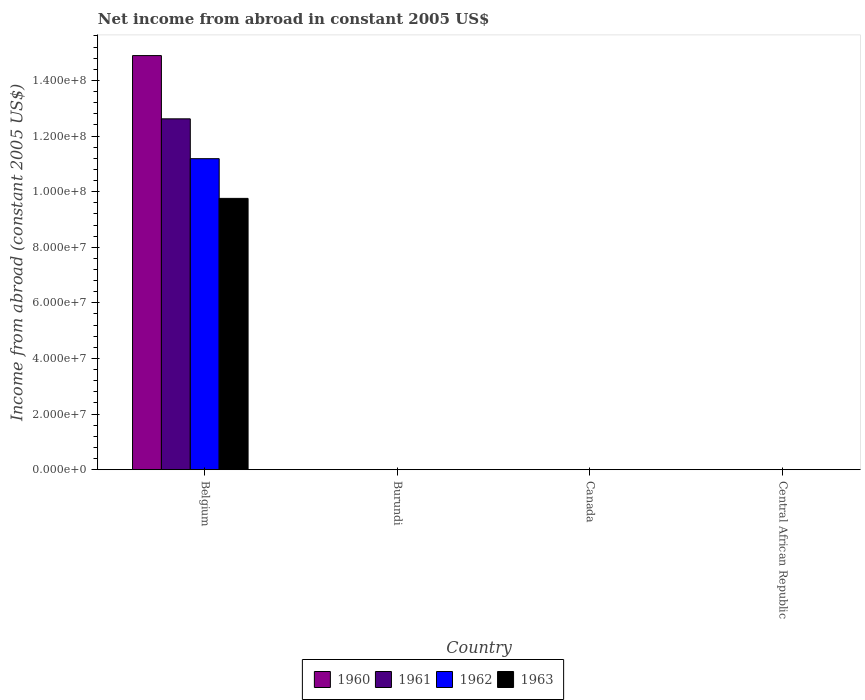Are the number of bars per tick equal to the number of legend labels?
Give a very brief answer. No. Are the number of bars on each tick of the X-axis equal?
Keep it short and to the point. No. In how many cases, is the number of bars for a given country not equal to the number of legend labels?
Make the answer very short. 3. What is the net income from abroad in 1962 in Belgium?
Keep it short and to the point. 1.12e+08. Across all countries, what is the maximum net income from abroad in 1961?
Provide a succinct answer. 1.26e+08. Across all countries, what is the minimum net income from abroad in 1960?
Offer a terse response. 0. In which country was the net income from abroad in 1960 maximum?
Offer a terse response. Belgium. What is the total net income from abroad in 1962 in the graph?
Give a very brief answer. 1.12e+08. What is the difference between the net income from abroad in 1962 in Belgium and the net income from abroad in 1963 in Canada?
Your response must be concise. 1.12e+08. What is the average net income from abroad in 1961 per country?
Offer a terse response. 3.15e+07. What is the difference between the net income from abroad of/in 1960 and net income from abroad of/in 1963 in Belgium?
Give a very brief answer. 5.14e+07. What is the difference between the highest and the lowest net income from abroad in 1962?
Offer a very short reply. 1.12e+08. How many bars are there?
Provide a succinct answer. 4. Are the values on the major ticks of Y-axis written in scientific E-notation?
Your response must be concise. Yes. Does the graph contain grids?
Your answer should be compact. No. Where does the legend appear in the graph?
Provide a succinct answer. Bottom center. What is the title of the graph?
Your answer should be very brief. Net income from abroad in constant 2005 US$. Does "2015" appear as one of the legend labels in the graph?
Provide a succinct answer. No. What is the label or title of the Y-axis?
Offer a very short reply. Income from abroad (constant 2005 US$). What is the Income from abroad (constant 2005 US$) in 1960 in Belgium?
Keep it short and to the point. 1.49e+08. What is the Income from abroad (constant 2005 US$) of 1961 in Belgium?
Ensure brevity in your answer.  1.26e+08. What is the Income from abroad (constant 2005 US$) of 1962 in Belgium?
Give a very brief answer. 1.12e+08. What is the Income from abroad (constant 2005 US$) in 1963 in Belgium?
Keep it short and to the point. 9.76e+07. What is the Income from abroad (constant 2005 US$) in 1960 in Burundi?
Your answer should be compact. 0. What is the Income from abroad (constant 2005 US$) in 1963 in Burundi?
Your answer should be very brief. 0. What is the Income from abroad (constant 2005 US$) in 1961 in Canada?
Your answer should be very brief. 0. What is the Income from abroad (constant 2005 US$) in 1962 in Canada?
Your answer should be very brief. 0. What is the Income from abroad (constant 2005 US$) in 1963 in Canada?
Your response must be concise. 0. What is the Income from abroad (constant 2005 US$) of 1961 in Central African Republic?
Keep it short and to the point. 0. What is the Income from abroad (constant 2005 US$) in 1962 in Central African Republic?
Your response must be concise. 0. What is the Income from abroad (constant 2005 US$) in 1963 in Central African Republic?
Provide a short and direct response. 0. Across all countries, what is the maximum Income from abroad (constant 2005 US$) of 1960?
Keep it short and to the point. 1.49e+08. Across all countries, what is the maximum Income from abroad (constant 2005 US$) in 1961?
Offer a very short reply. 1.26e+08. Across all countries, what is the maximum Income from abroad (constant 2005 US$) in 1962?
Keep it short and to the point. 1.12e+08. Across all countries, what is the maximum Income from abroad (constant 2005 US$) of 1963?
Your response must be concise. 9.76e+07. Across all countries, what is the minimum Income from abroad (constant 2005 US$) in 1960?
Offer a terse response. 0. Across all countries, what is the minimum Income from abroad (constant 2005 US$) in 1961?
Make the answer very short. 0. Across all countries, what is the minimum Income from abroad (constant 2005 US$) of 1962?
Make the answer very short. 0. What is the total Income from abroad (constant 2005 US$) of 1960 in the graph?
Ensure brevity in your answer.  1.49e+08. What is the total Income from abroad (constant 2005 US$) in 1961 in the graph?
Make the answer very short. 1.26e+08. What is the total Income from abroad (constant 2005 US$) in 1962 in the graph?
Your answer should be very brief. 1.12e+08. What is the total Income from abroad (constant 2005 US$) of 1963 in the graph?
Offer a terse response. 9.76e+07. What is the average Income from abroad (constant 2005 US$) in 1960 per country?
Ensure brevity in your answer.  3.72e+07. What is the average Income from abroad (constant 2005 US$) in 1961 per country?
Offer a very short reply. 3.15e+07. What is the average Income from abroad (constant 2005 US$) in 1962 per country?
Provide a succinct answer. 2.80e+07. What is the average Income from abroad (constant 2005 US$) of 1963 per country?
Keep it short and to the point. 2.44e+07. What is the difference between the Income from abroad (constant 2005 US$) in 1960 and Income from abroad (constant 2005 US$) in 1961 in Belgium?
Offer a terse response. 2.27e+07. What is the difference between the Income from abroad (constant 2005 US$) in 1960 and Income from abroad (constant 2005 US$) in 1962 in Belgium?
Give a very brief answer. 3.71e+07. What is the difference between the Income from abroad (constant 2005 US$) of 1960 and Income from abroad (constant 2005 US$) of 1963 in Belgium?
Offer a very short reply. 5.14e+07. What is the difference between the Income from abroad (constant 2005 US$) of 1961 and Income from abroad (constant 2005 US$) of 1962 in Belgium?
Your answer should be very brief. 1.43e+07. What is the difference between the Income from abroad (constant 2005 US$) in 1961 and Income from abroad (constant 2005 US$) in 1963 in Belgium?
Give a very brief answer. 2.86e+07. What is the difference between the Income from abroad (constant 2005 US$) of 1962 and Income from abroad (constant 2005 US$) of 1963 in Belgium?
Provide a succinct answer. 1.43e+07. What is the difference between the highest and the lowest Income from abroad (constant 2005 US$) of 1960?
Offer a very short reply. 1.49e+08. What is the difference between the highest and the lowest Income from abroad (constant 2005 US$) in 1961?
Make the answer very short. 1.26e+08. What is the difference between the highest and the lowest Income from abroad (constant 2005 US$) in 1962?
Ensure brevity in your answer.  1.12e+08. What is the difference between the highest and the lowest Income from abroad (constant 2005 US$) of 1963?
Your answer should be compact. 9.76e+07. 